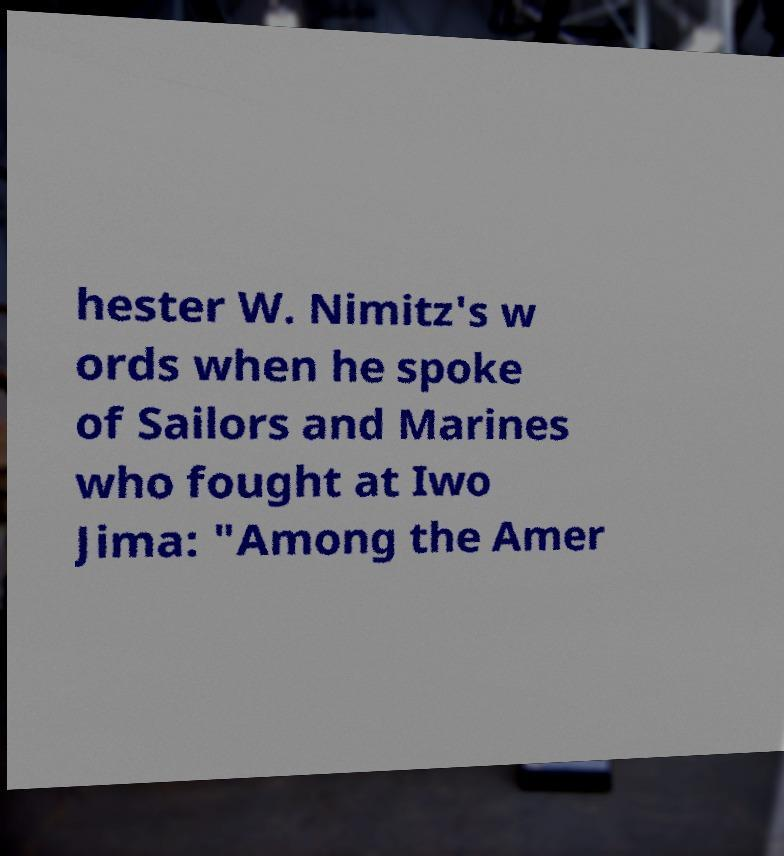What messages or text are displayed in this image? I need them in a readable, typed format. hester W. Nimitz's w ords when he spoke of Sailors and Marines who fought at Iwo Jima: "Among the Amer 